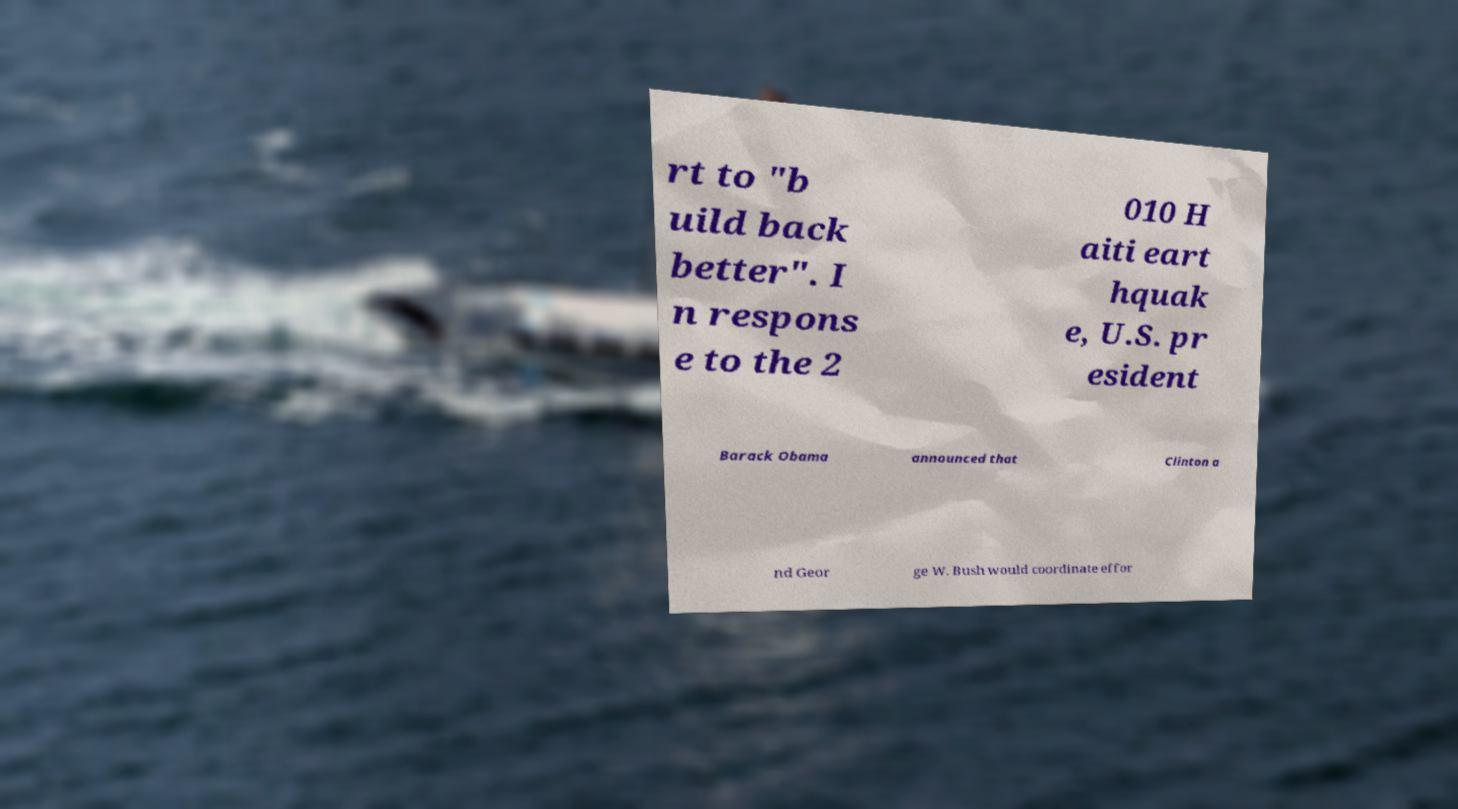Could you extract and type out the text from this image? rt to "b uild back better". I n respons e to the 2 010 H aiti eart hquak e, U.S. pr esident Barack Obama announced that Clinton a nd Geor ge W. Bush would coordinate effor 